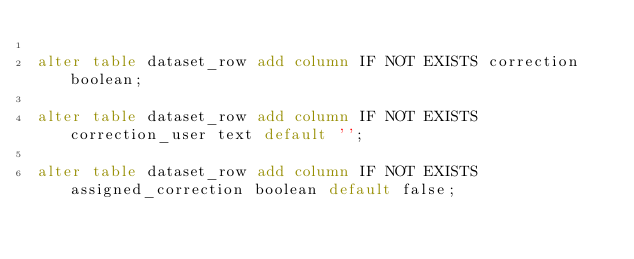<code> <loc_0><loc_0><loc_500><loc_500><_SQL_>
alter table dataset_row add column IF NOT EXISTS correction boolean;

alter table dataset_row add column IF NOT EXISTS correction_user text default '';

alter table dataset_row add column IF NOT EXISTS assigned_correction boolean default false;


</code> 